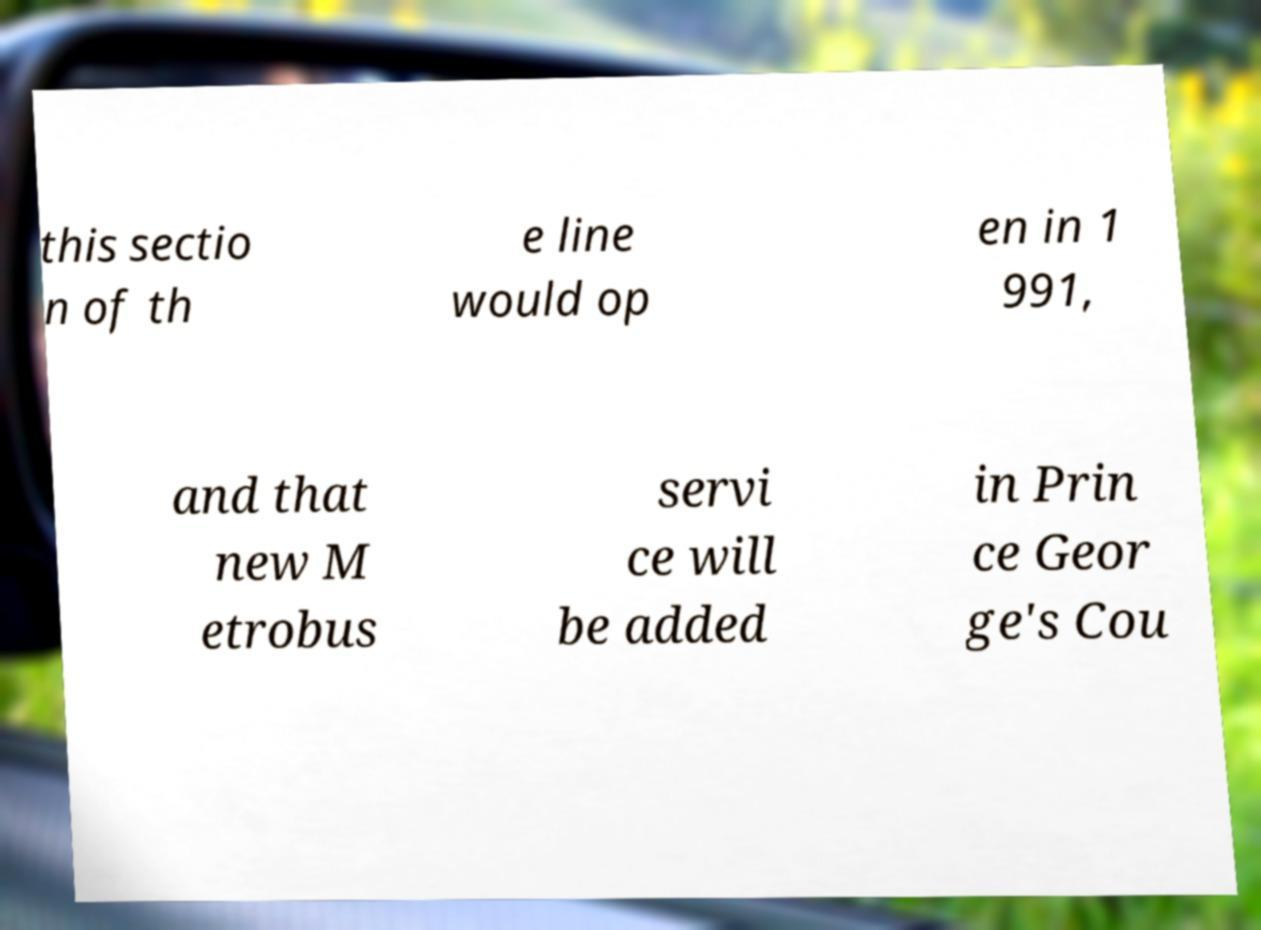For documentation purposes, I need the text within this image transcribed. Could you provide that? this sectio n of th e line would op en in 1 991, and that new M etrobus servi ce will be added in Prin ce Geor ge's Cou 